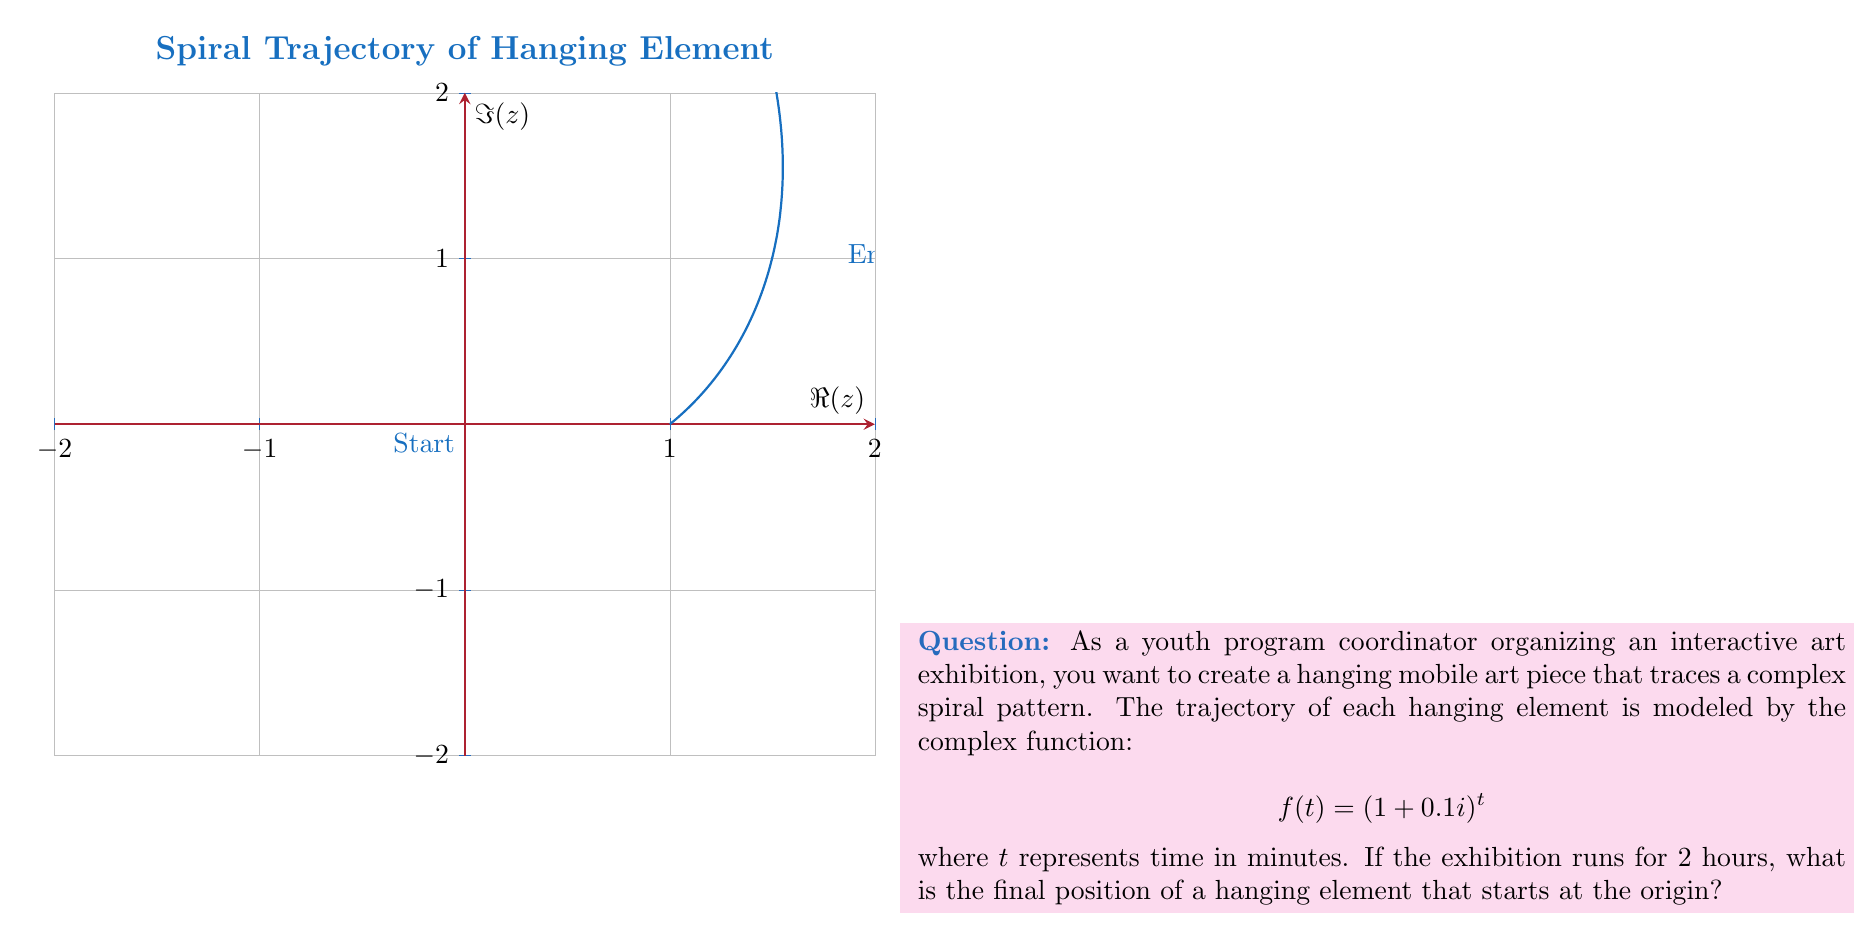Could you help me with this problem? Let's approach this step-by-step:

1) The given function is $f(t) = (1+0.1i)^t$, where $t$ is in minutes.

2) The exhibition runs for 2 hours, which is 120 minutes. So we need to find $f(120)$.

3) To calculate this, we can use the exponential form of complex numbers:

   $$(1+0.1i)^t = e^{t \ln(1+0.1i)}$$

4) First, let's calculate $\ln(1+0.1i)$:
   
   $r = \sqrt{1^2 + 0.1^2} = \sqrt{1.01} \approx 1.004987562$
   $\theta = \arctan(0.1/1) \approx 0.099668652$

   So, $\ln(1+0.1i) = \ln(r) + i\theta \approx 0.004975124 + 0.099668652i$

5) Now we can calculate:

   $f(120) = e^{120(0.004975124 + 0.099668652i)}$
           $= e^{0.597014880 + 11.96023824i}$

6) Converting back to $a+bi$ form:

   $f(120) = e^{0.597014880}(\cos(11.96023824) + i\sin(11.96023824))$
           $\approx 1.816729716 - 0.235004792i$
Answer: $1.816729716 - 0.235004792i$ 